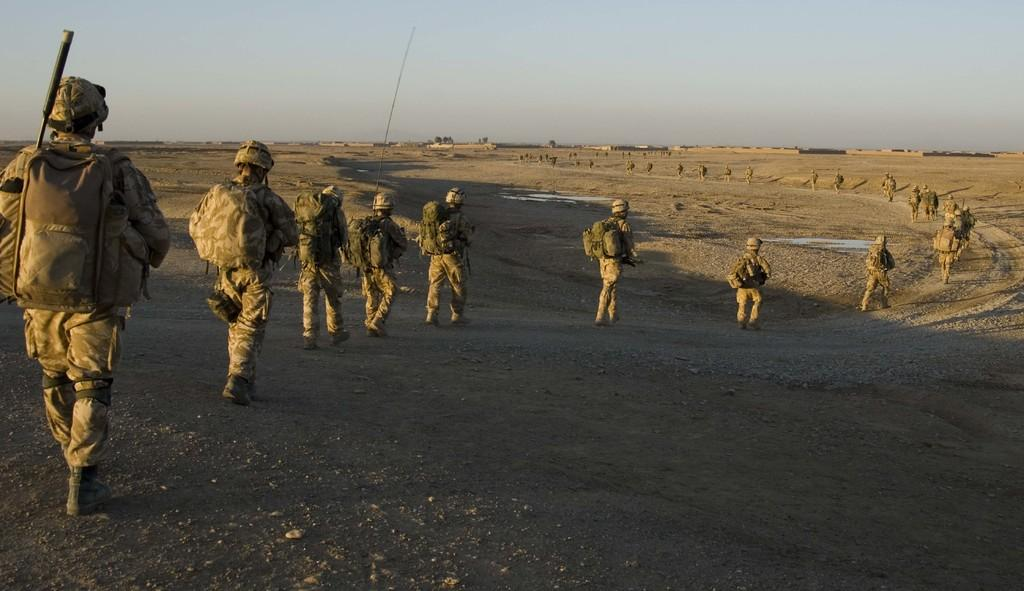How many people are in the image? There is a group of persons in the image. What are the persons in the image doing? The persons are walking on the ground. What can be seen under the persons' feet in the image? There is ground visible in the image. What is visible in the background of the image? There are buildings, trees, and the sky visible in the background of the image. What type of vacation is the group of persons enjoying in the image? The image does not provide any information about a vacation or the group's intentions; it simply shows them walking on the ground. 